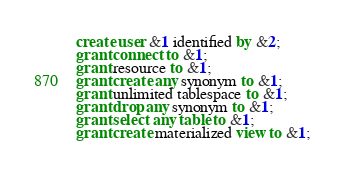<code> <loc_0><loc_0><loc_500><loc_500><_SQL_>create user &1 identified by &2;
grant connect to &1;
grant resource to &1;
grant create any synonym to &1;
grant unlimited tablespace to &1;
grant drop any synonym to &1;
grant select any table to &1;
grant create materialized view to &1;

</code> 